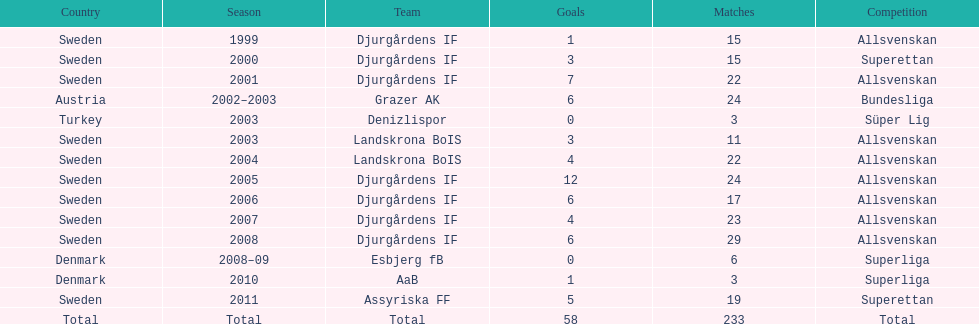What country is team djurgårdens if not from? Sweden. 